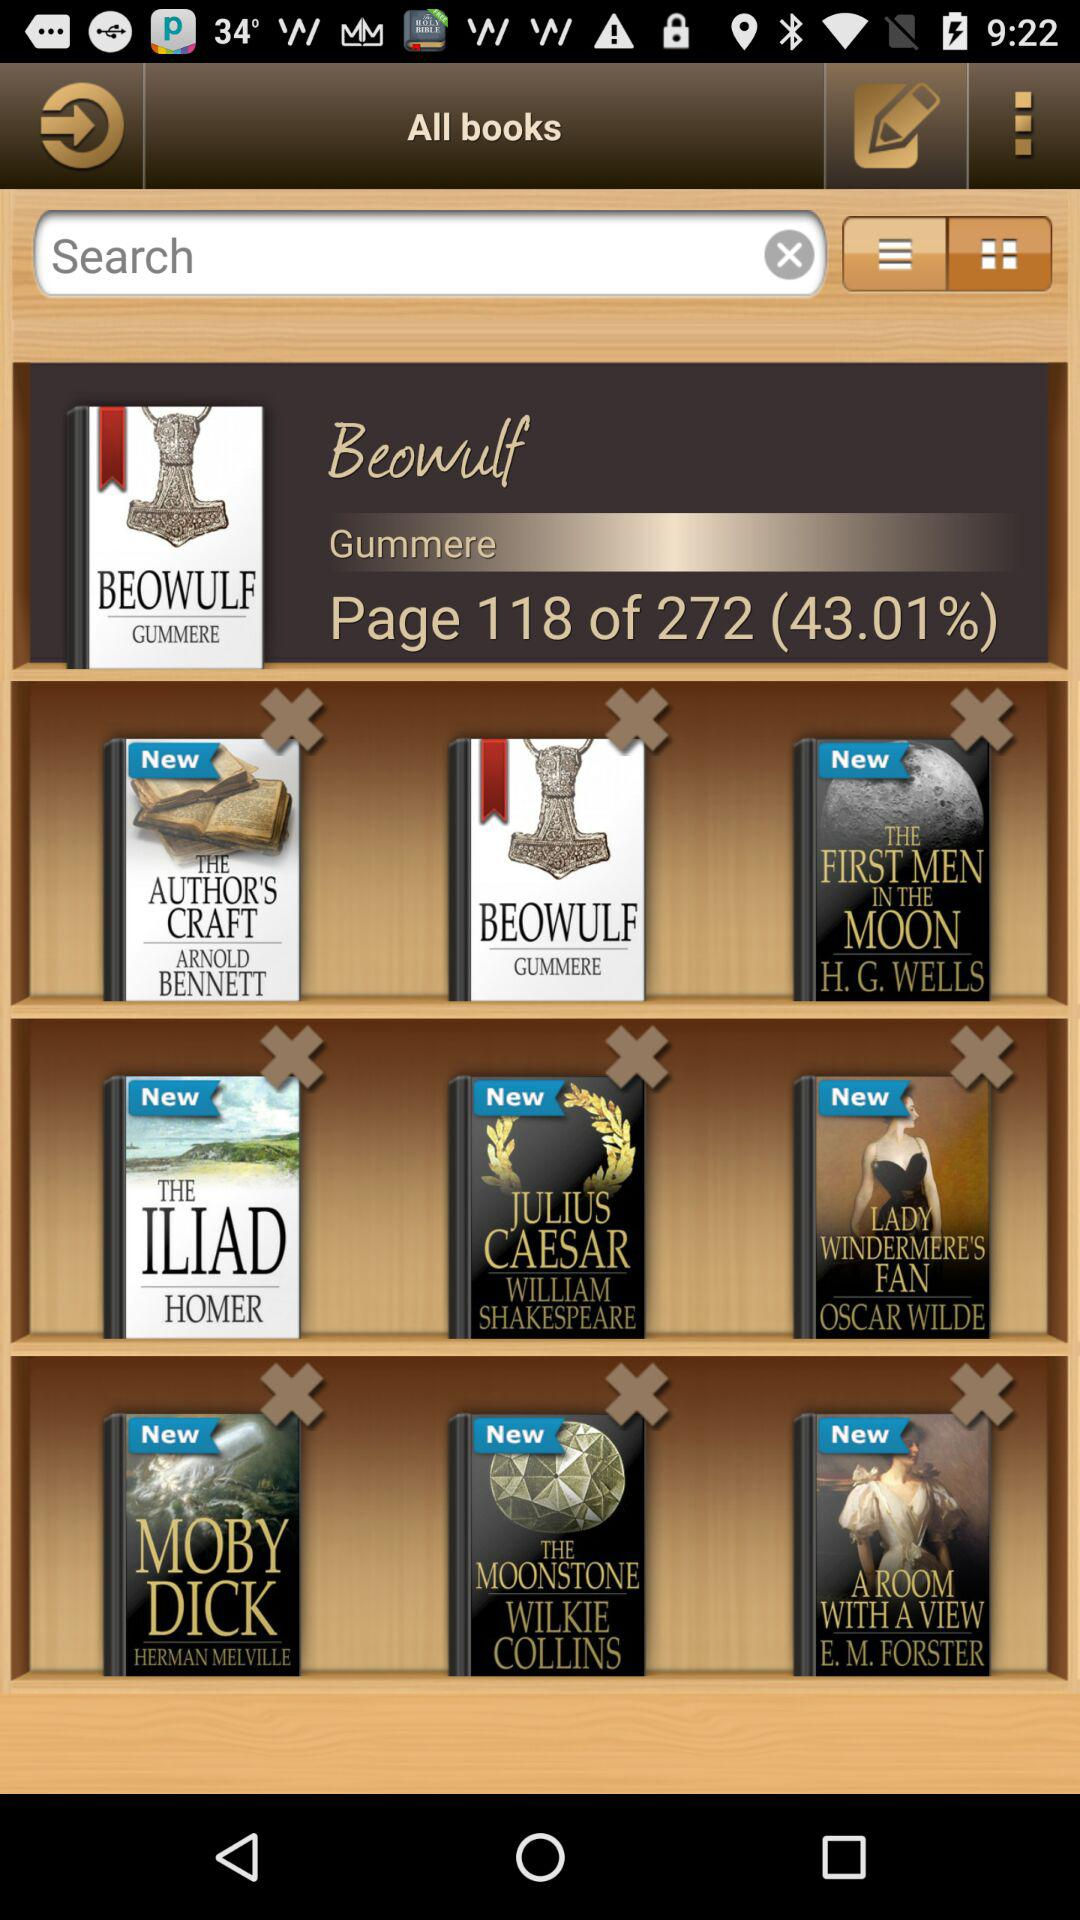How many pages are in "Beowulf"? There are 272 pages in "Beowulf". 